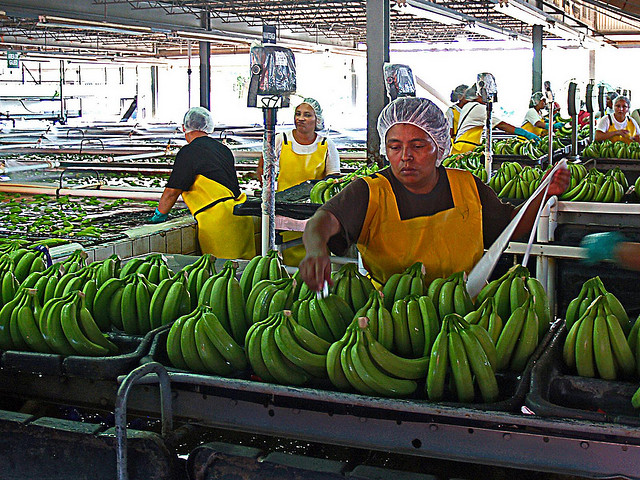What does the hair cap prevent?
A. dandruff
B. stray hairs
C. distraction
D. flies
Answer with the option's letter from the given choices directly. B 